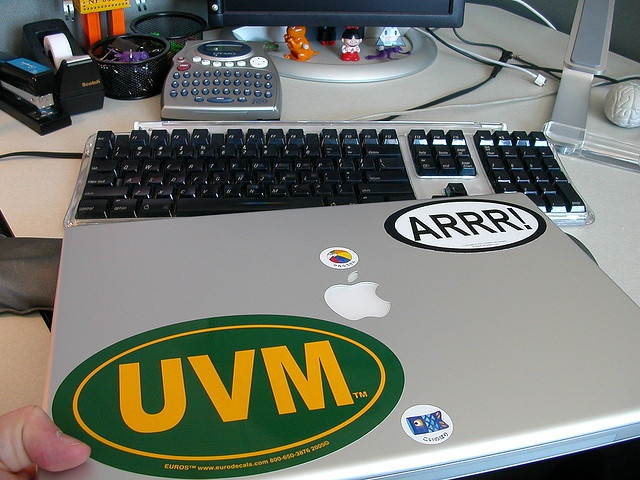Describe the objects in this image and their specific colors. I can see laptop in gray, darkgray, darkgreen, white, and orange tones, keyboard in gray, black, darkgray, and lightgray tones, tv in gray, black, navy, and blue tones, and people in gray, brown, and maroon tones in this image. 